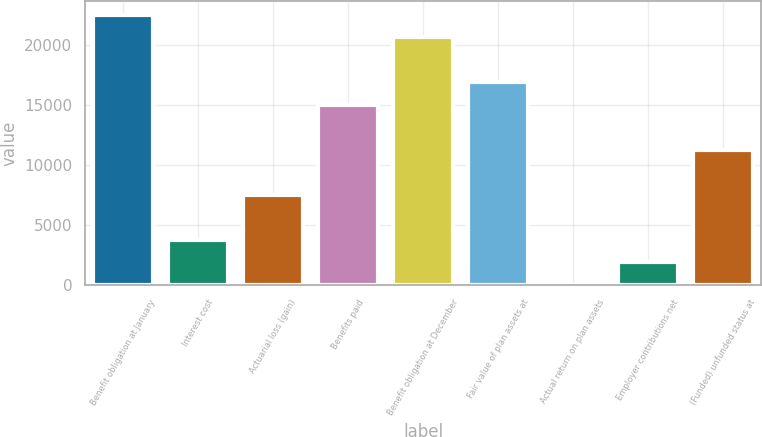Convert chart. <chart><loc_0><loc_0><loc_500><loc_500><bar_chart><fcel>Benefit obligation at January<fcel>Interest cost<fcel>Actuarial loss (gain)<fcel>Benefits paid<fcel>Benefit obligation at December<fcel>Fair value of plan assets at<fcel>Actual return on plan assets<fcel>Employer contributions net<fcel>(Funded) unfunded status at<nl><fcel>22524.8<fcel>3765.8<fcel>7517.6<fcel>15021.2<fcel>20648.9<fcel>16897.1<fcel>14<fcel>1889.9<fcel>11269.4<nl></chart> 